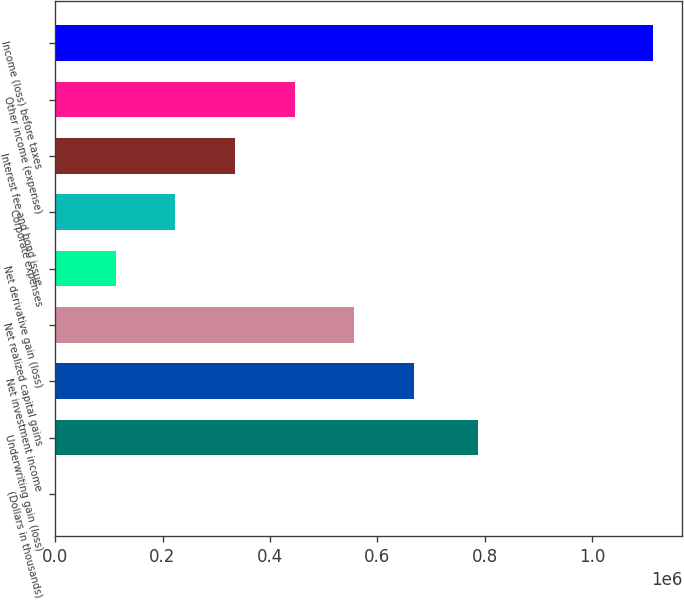Convert chart. <chart><loc_0><loc_0><loc_500><loc_500><bar_chart><fcel>(Dollars in thousands)<fcel>Underwriting gain (loss)<fcel>Net investment income<fcel>Net realized capital gains<fcel>Net derivative gain (loss)<fcel>Corporate expenses<fcel>Interest fee and bond issue<fcel>Other income (expense)<fcel>Income (loss) before taxes<nl><fcel>2015<fcel>787412<fcel>667940<fcel>556952<fcel>113002<fcel>223990<fcel>334978<fcel>445965<fcel>1.11189e+06<nl></chart> 